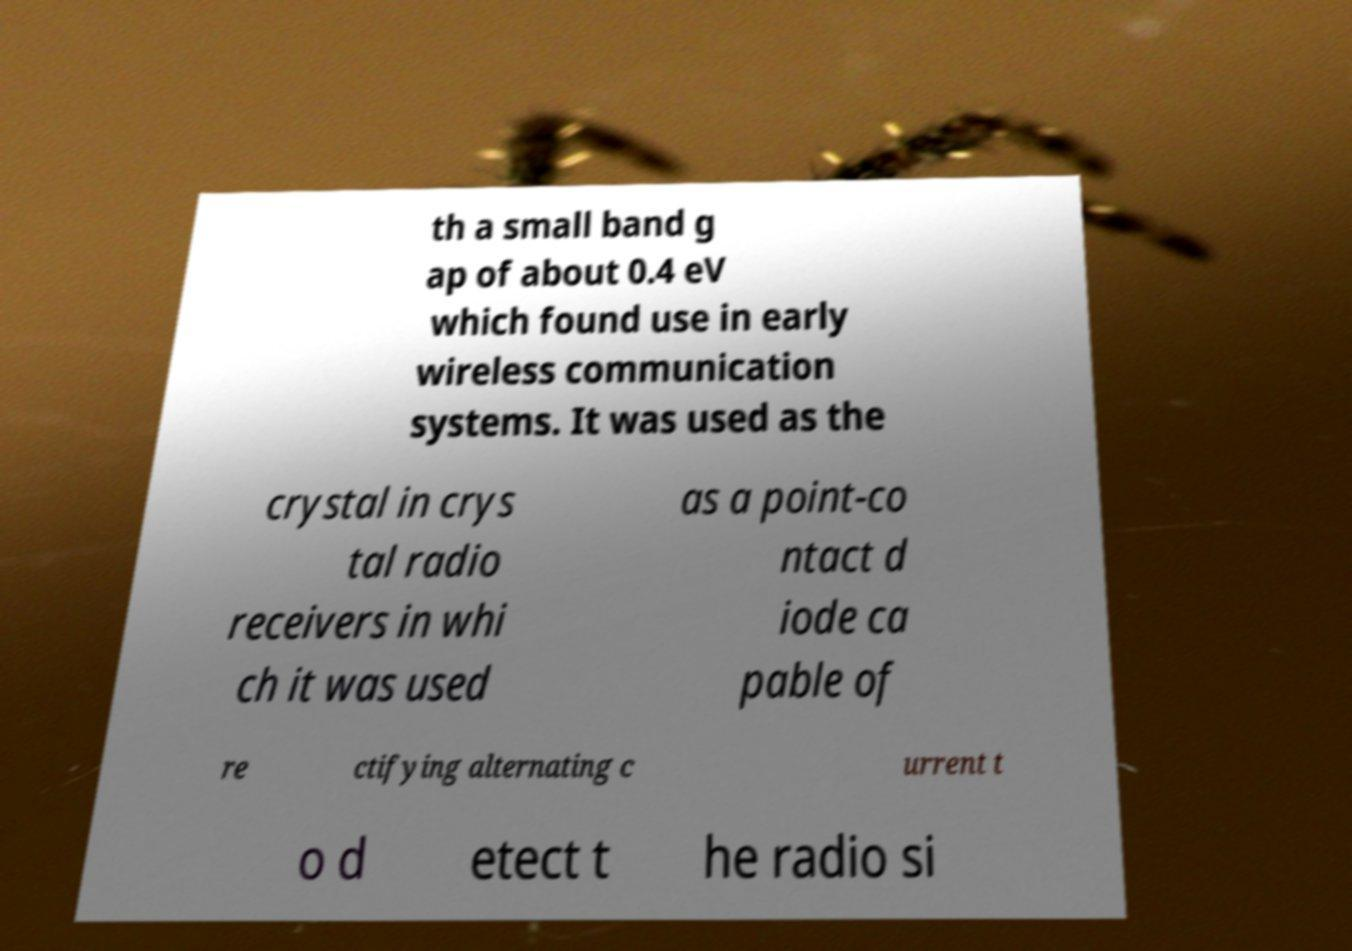Can you accurately transcribe the text from the provided image for me? th a small band g ap of about 0.4 eV which found use in early wireless communication systems. It was used as the crystal in crys tal radio receivers in whi ch it was used as a point-co ntact d iode ca pable of re ctifying alternating c urrent t o d etect t he radio si 